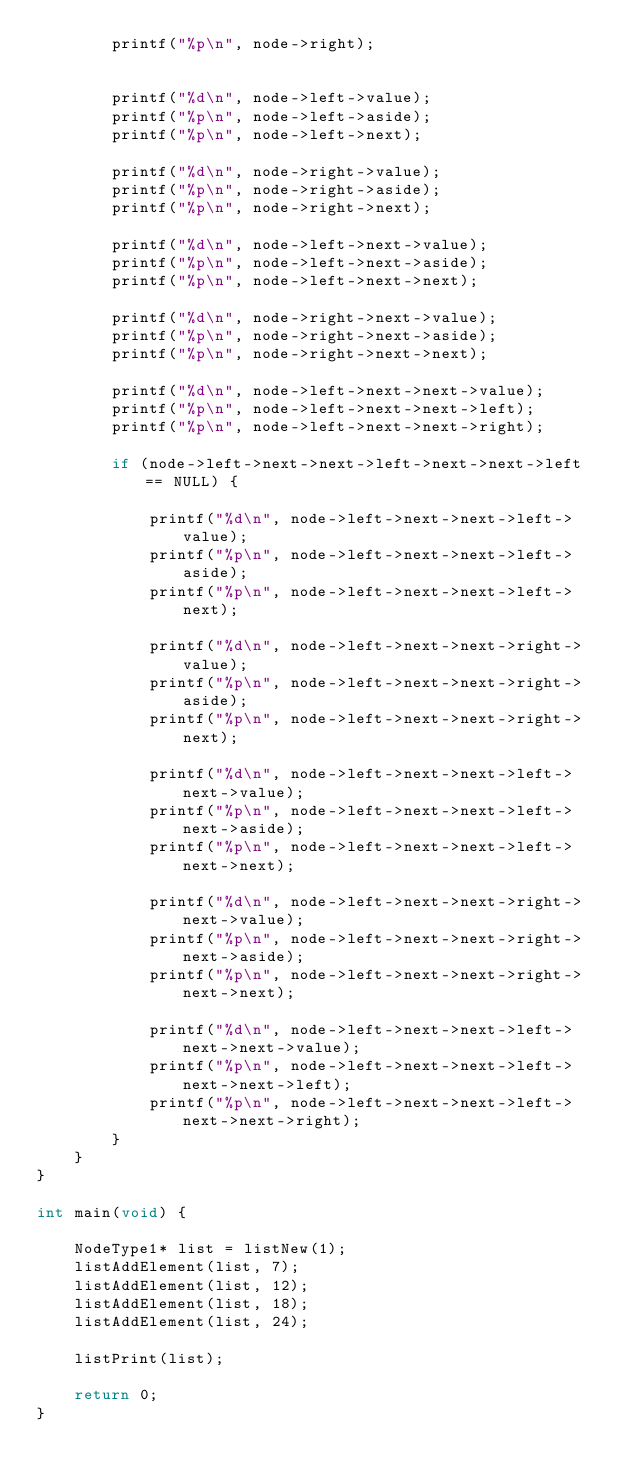Convert code to text. <code><loc_0><loc_0><loc_500><loc_500><_C++_>        printf("%p\n", node->right);


        printf("%d\n", node->left->value);
        printf("%p\n", node->left->aside);
        printf("%p\n", node->left->next);

        printf("%d\n", node->right->value);
        printf("%p\n", node->right->aside);
        printf("%p\n", node->right->next);

        printf("%d\n", node->left->next->value);
        printf("%p\n", node->left->next->aside);
        printf("%p\n", node->left->next->next);

        printf("%d\n", node->right->next->value);
        printf("%p\n", node->right->next->aside);
        printf("%p\n", node->right->next->next);

        printf("%d\n", node->left->next->next->value);
        printf("%p\n", node->left->next->next->left);
        printf("%p\n", node->left->next->next->right);

        if (node->left->next->next->left->next->next->left == NULL) {

            printf("%d\n", node->left->next->next->left->value);
            printf("%p\n", node->left->next->next->left->aside);
            printf("%p\n", node->left->next->next->left->next);

            printf("%d\n", node->left->next->next->right->value);
            printf("%p\n", node->left->next->next->right->aside);
            printf("%p\n", node->left->next->next->right->next);

            printf("%d\n", node->left->next->next->left->next->value);
            printf("%p\n", node->left->next->next->left->next->aside);
            printf("%p\n", node->left->next->next->left->next->next);

            printf("%d\n", node->left->next->next->right->next->value);
            printf("%p\n", node->left->next->next->right->next->aside);
            printf("%p\n", node->left->next->next->right->next->next);

            printf("%d\n", node->left->next->next->left->next->next->value);
            printf("%p\n", node->left->next->next->left->next->next->left);
            printf("%p\n", node->left->next->next->left->next->next->right);
        }
    }
}

int main(void) {

    NodeType1* list = listNew(1);
    listAddElement(list, 7);
    listAddElement(list, 12);
    listAddElement(list, 18);
    listAddElement(list, 24);

    listPrint(list);

    return 0;
}
</code> 